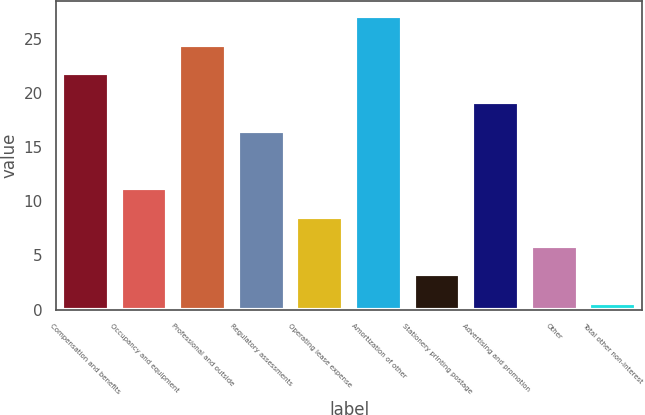<chart> <loc_0><loc_0><loc_500><loc_500><bar_chart><fcel>Compensation and benefits<fcel>Occupancy and equipment<fcel>Professional and outside<fcel>Regulatory assessments<fcel>Operating lease expense<fcel>Amortization of other<fcel>Stationery printing postage<fcel>Advertising and promotion<fcel>Other<fcel>Total other non-interest<nl><fcel>21.8<fcel>11.2<fcel>24.45<fcel>16.5<fcel>8.55<fcel>27.1<fcel>3.25<fcel>19.15<fcel>5.9<fcel>0.6<nl></chart> 